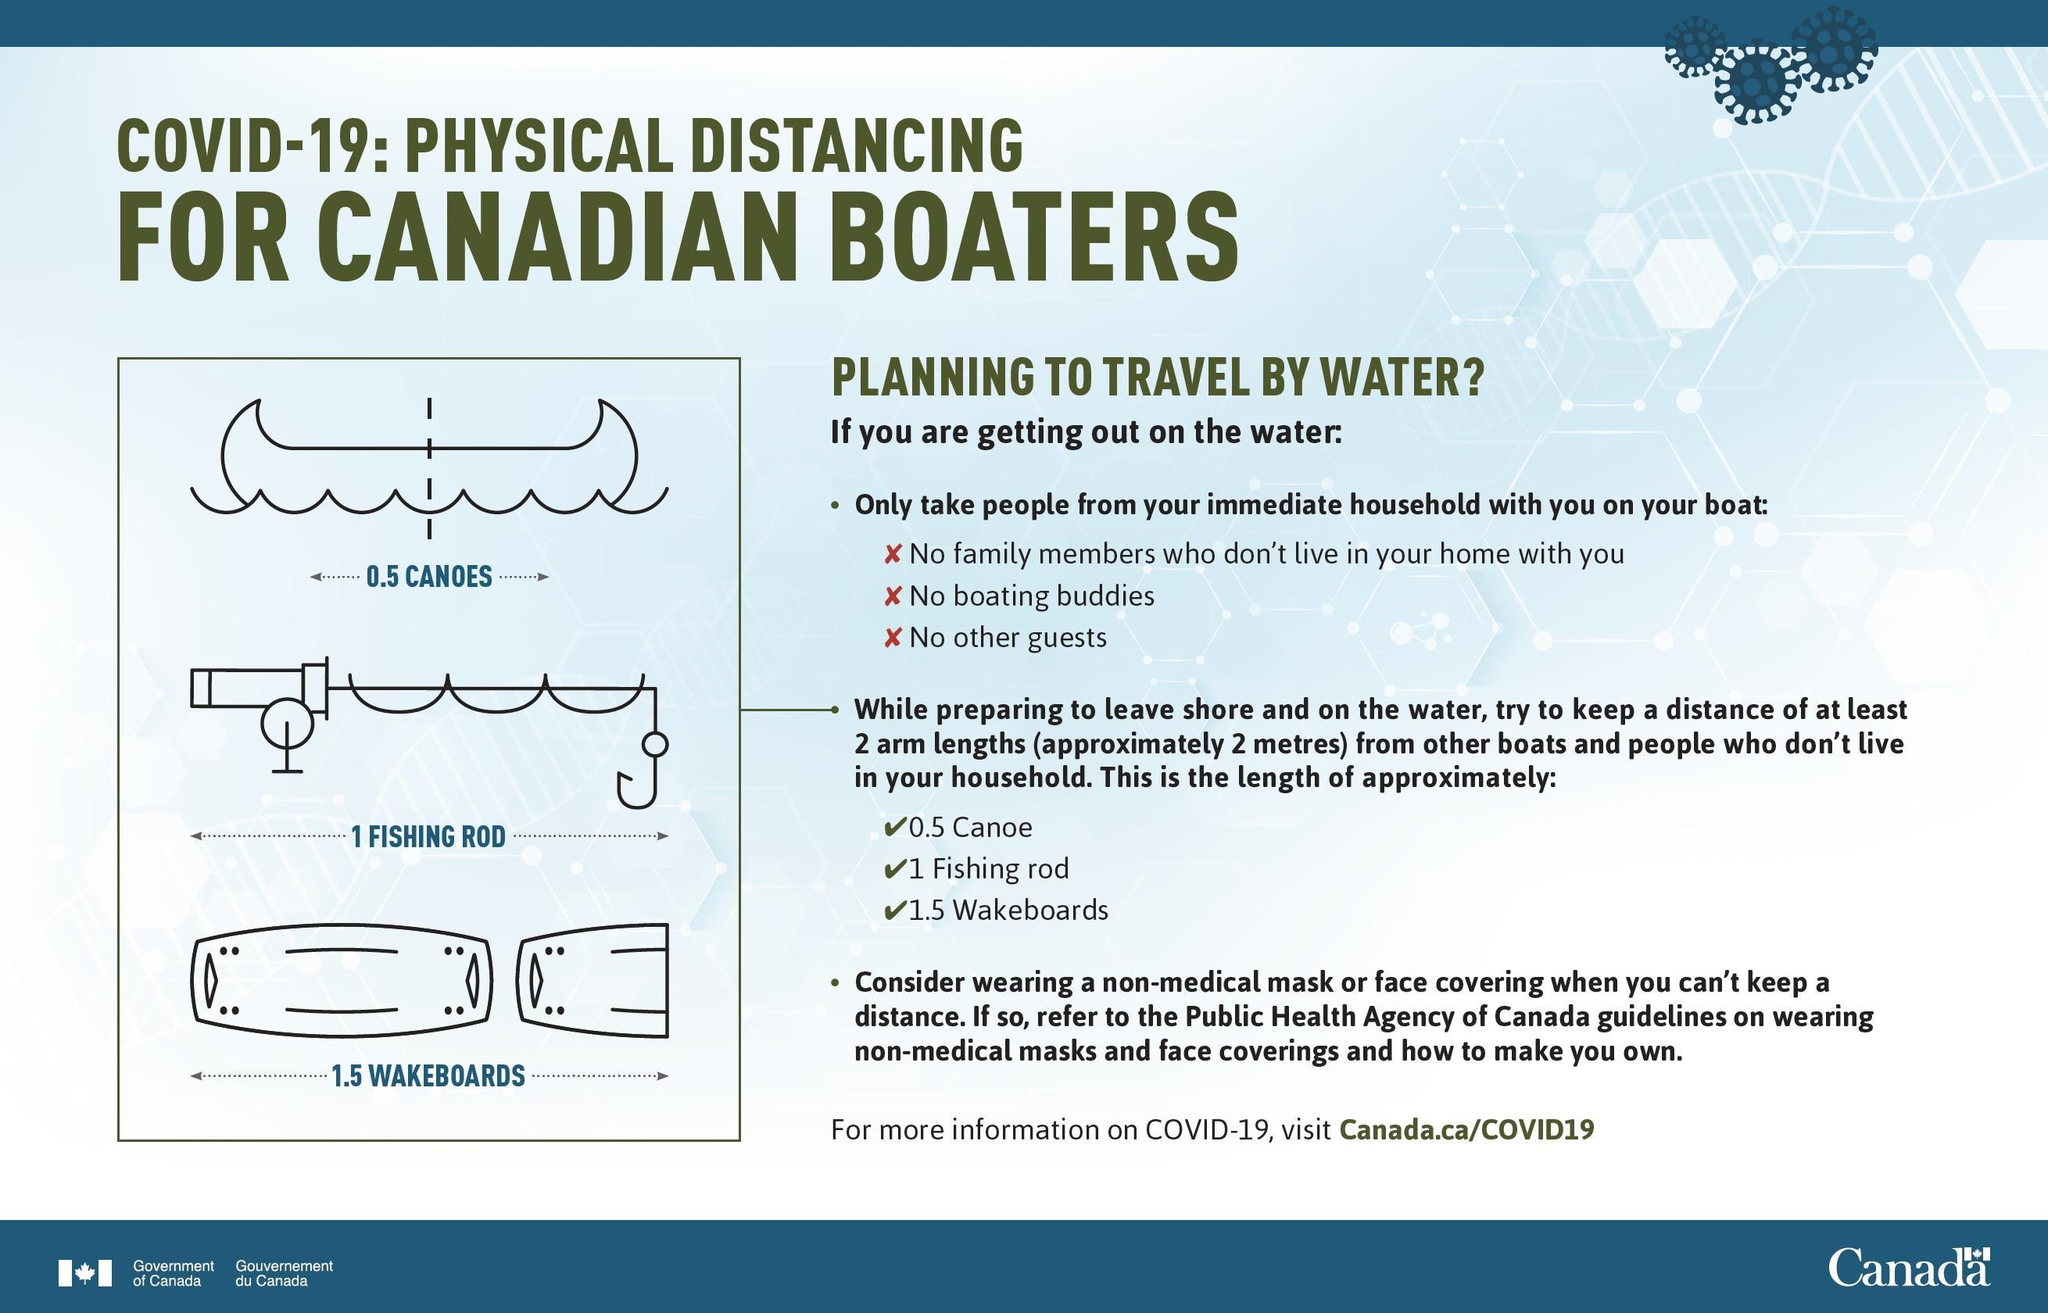The length of how many fishing rods will be equal to 6 metres
Answer the question with a short phrase. 3 2 arm lengths or 2 metres is equal to what as per diagrams 0.5 canoe, 1 fishing rod, 1.5 wakeboards What is the length in metres of 1 canoe 4 